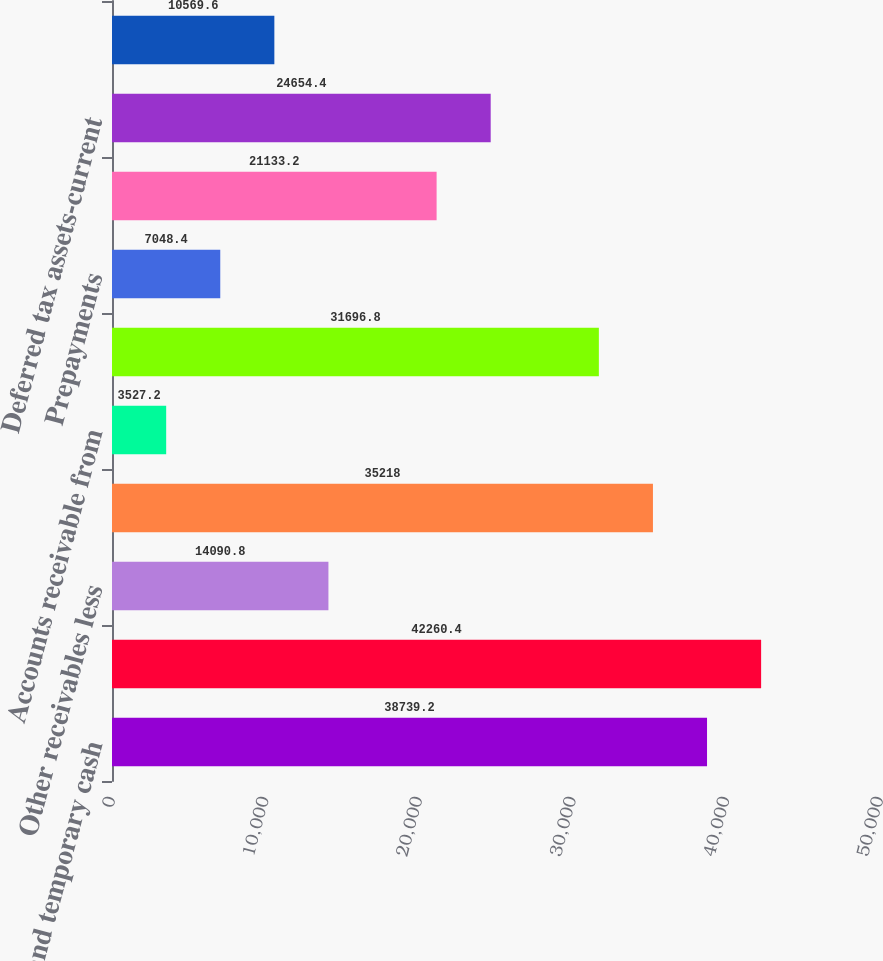Convert chart. <chart><loc_0><loc_0><loc_500><loc_500><bar_chart><fcel>Cash and temporary cash<fcel>Accounts receivable -<fcel>Other receivables less<fcel>Accrued unbilled revenue<fcel>Accounts receivable from<fcel>Fuel oil gas in storage<fcel>Prepayments<fcel>Regulatory assets<fcel>Deferred tax assets-current<fcel>Other current assets<nl><fcel>38739.2<fcel>42260.4<fcel>14090.8<fcel>35218<fcel>3527.2<fcel>31696.8<fcel>7048.4<fcel>21133.2<fcel>24654.4<fcel>10569.6<nl></chart> 